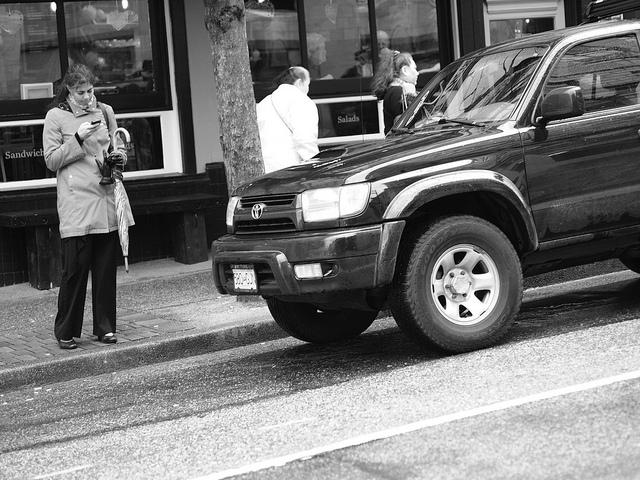Why is the woman looking down into her hand? Please explain your reasoning. answering text. She is checking her phone to respond to someone. 